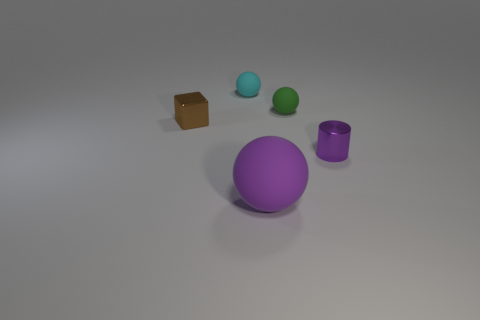Add 2 big matte balls. How many objects exist? 7 Subtract all blocks. How many objects are left? 4 Subtract all large matte spheres. Subtract all small metal blocks. How many objects are left? 3 Add 2 cyan rubber balls. How many cyan rubber balls are left? 3 Add 2 small cyan matte balls. How many small cyan matte balls exist? 3 Subtract 0 yellow cylinders. How many objects are left? 5 